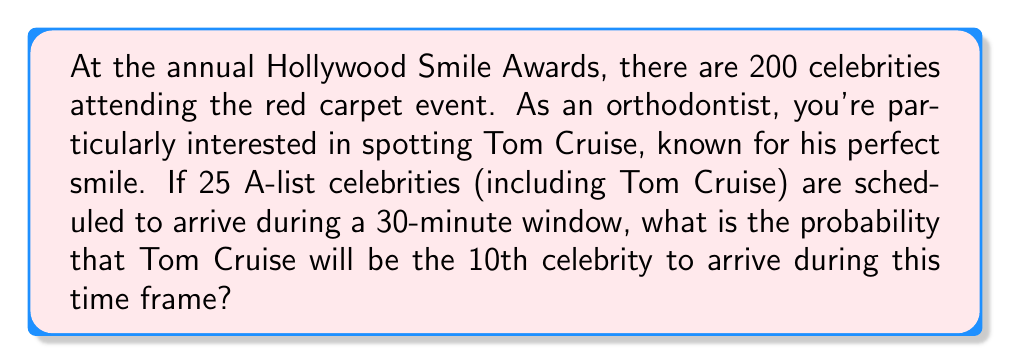Solve this math problem. Let's approach this step-by-step:

1) This is a problem of ordered arrangements, specifically a permutation.

2) We're interested in the probability of Tom Cruise being in the 10th position out of 25 possible positions.

3) For Tom Cruise to be 10th:
   - 9 celebrities must come before him
   - 15 celebrities must come after him
   - Tom Cruise himself occupies the 10th position

4) The number of ways to arrange 9 celebrities before Tom Cruise:
   $P(24,9) = \frac{24!}{(24-9)!} = \frac{24!}{15!}$

5) The number of ways to arrange 15 celebrities after Tom Cruise:
   $P(15,15) = 15!$

6) The total number of arrangements with Tom Cruise 10th:
   $\frac{24!}{15!} \times 15! = 24!$

7) The total number of possible arrangements of 25 celebrities:
   $25!$

8) Therefore, the probability is:

   $$P(\text{Tom Cruise 10th}) = \frac{24!}{25!} = \frac{1}{25}$$
Answer: $\frac{1}{25}$ 